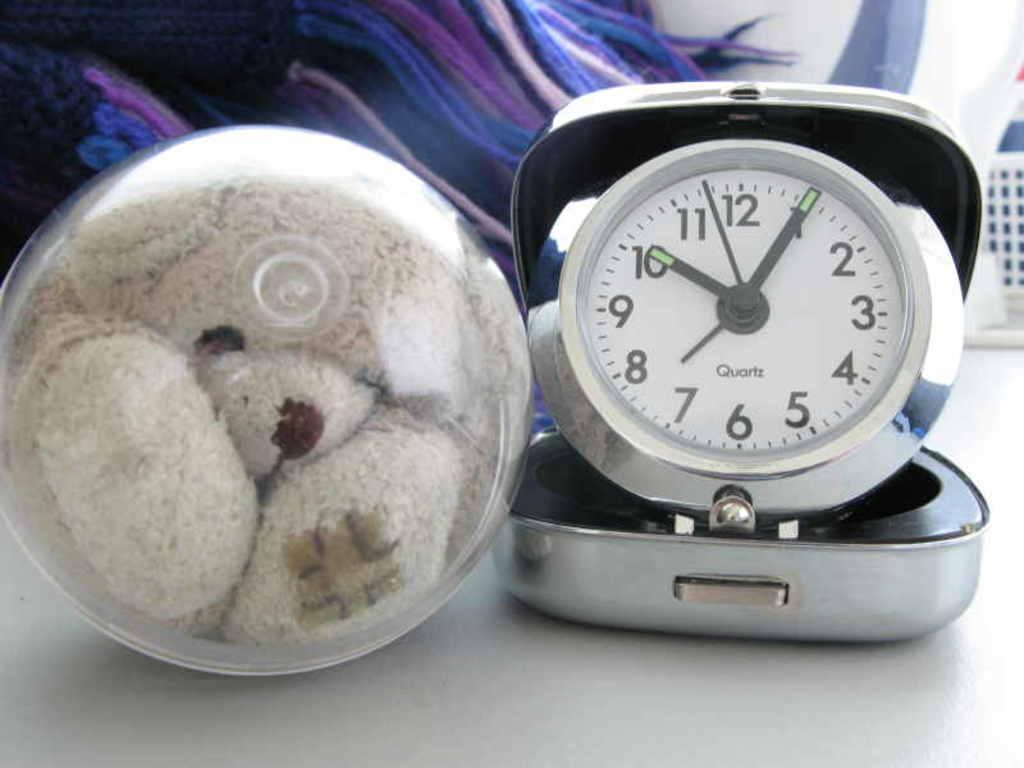<image>
Give a short and clear explanation of the subsequent image. A travel quartz alarm clock next to a teddy bear in a sphere. 